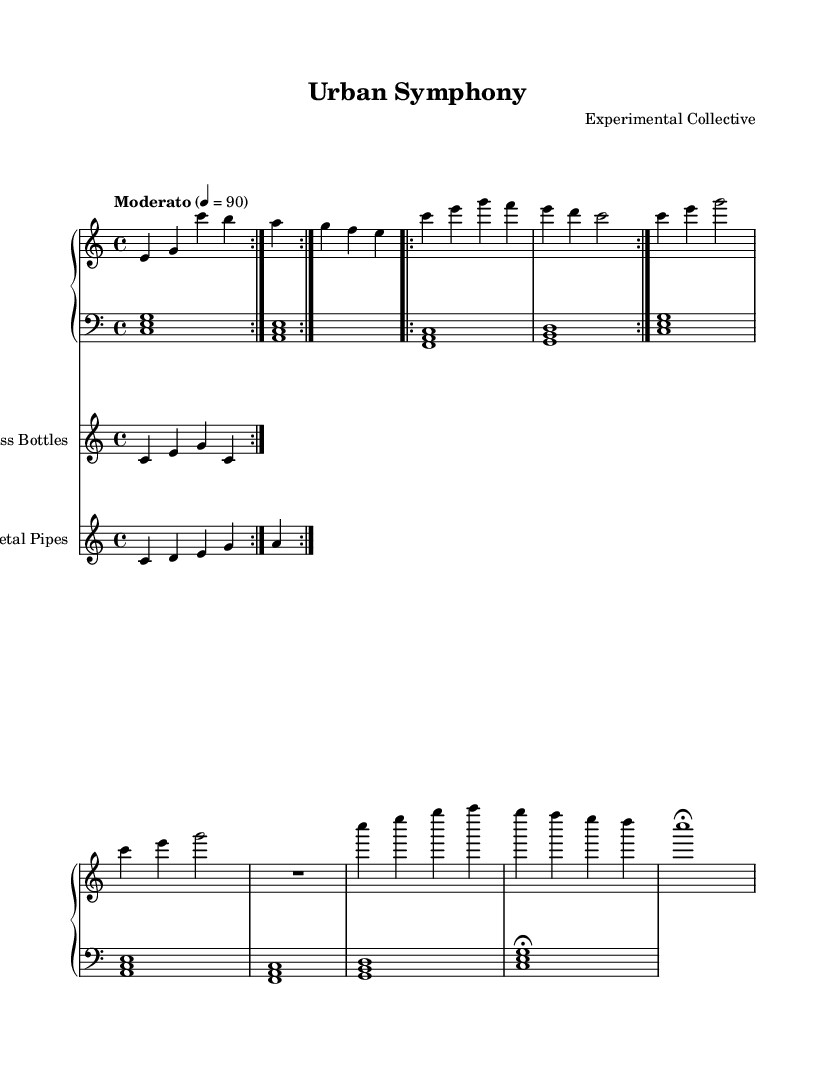What is the key signature of this music? The key signature is C major, which has no sharps or flats.
Answer: C major What is the time signature of this piece? The time signature is indicated by the number of beats per measure, which is written as 4 over 4 at the beginning of the score.
Answer: 4/4 What is the tempo marking for this composition? The tempo marking, indicated in Italian, is Moderato, which suggests a moderate speed at a rate of 90 beats per minute.
Answer: Moderato How many times is Section A repeated? The repeat notation, indicated by the volta markings, shows that Section A is executed two times.
Answer: 2 What instruments are used in this piece? The music features a Piano, Glass Bottles, and Metal Pipes, as indicated by their respective staff labels.
Answer: Piano, Glass Bottles, Metal Pipes What rhythmic pattern is played by the Glass Bottles? The Glass Bottles follow a repeating rhythm pattern that consists of four notes: c, e, g, and c, repeated multiple times.
Answer: c e g c What type of scale is used in the Metal Pipes section? The Metal Pipes section utilizes a pentatonic scale which includes the notes c, d, e, g, and a, repeated in a specific pattern.
Answer: Pentatonic scale 